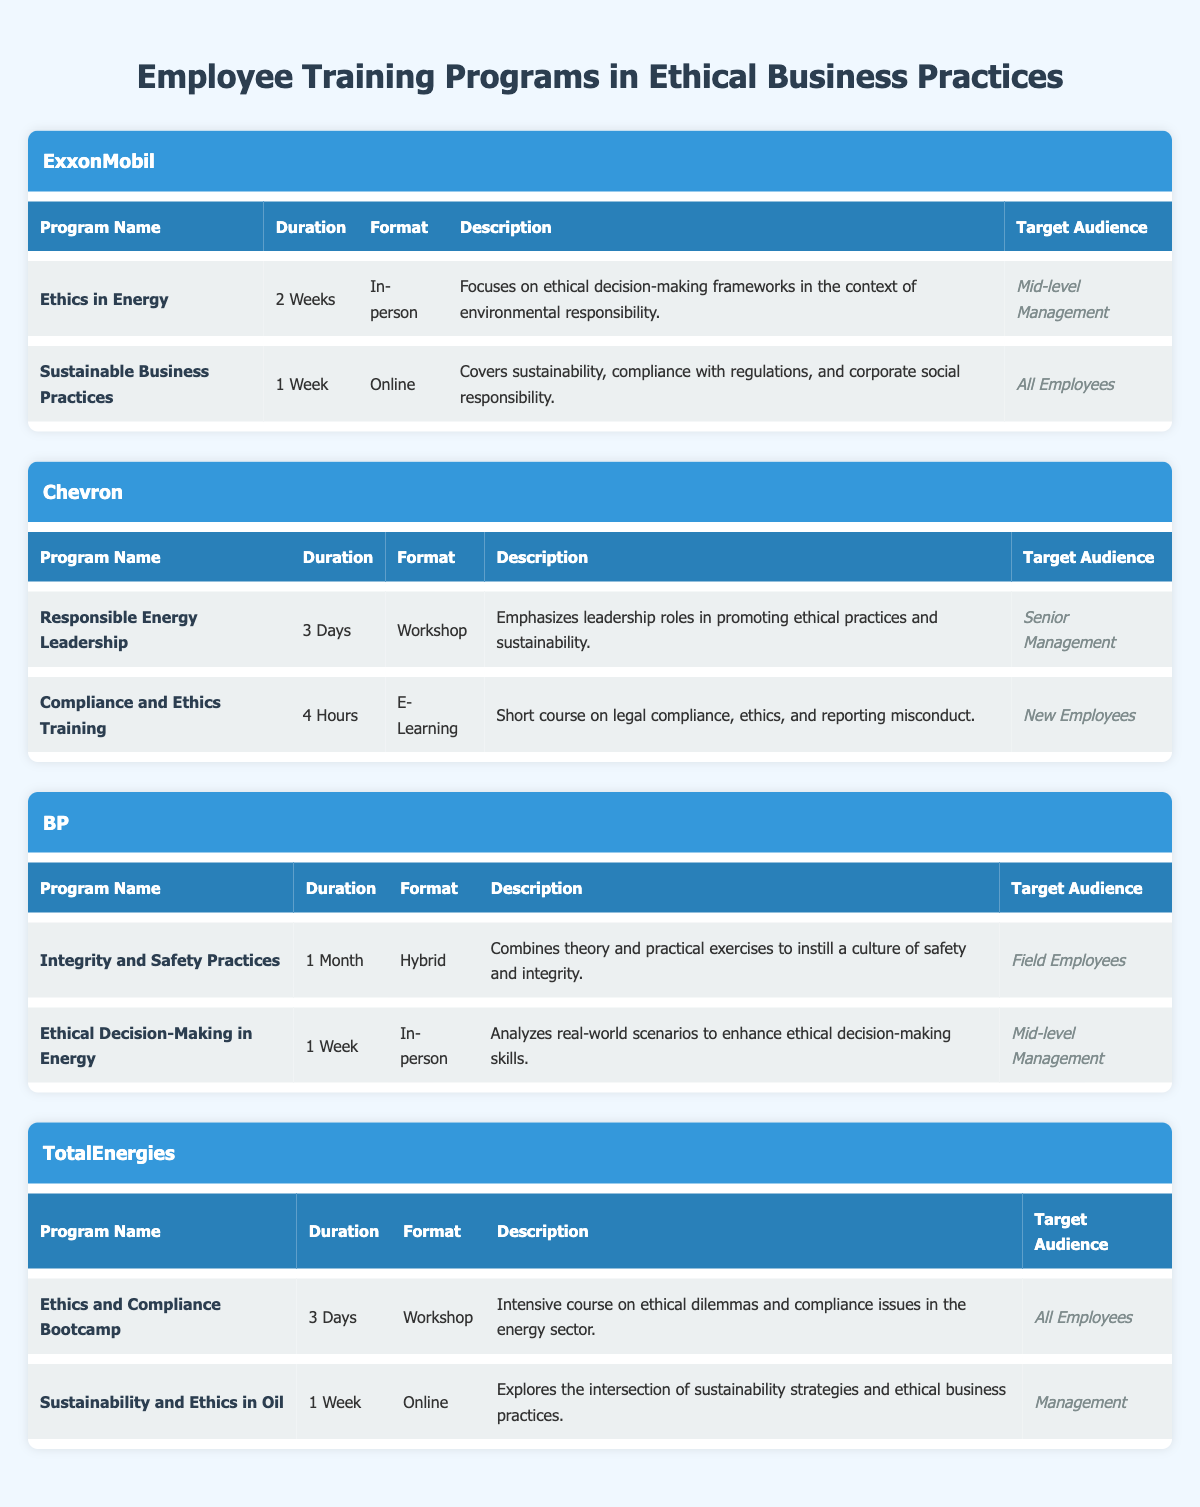What are the target audiences for the training programs at ExxonMobil? From the table, the target audiences listed under ExxonMobil's training programs are "Mid-level Management" for the "Ethics in Energy" program and "All Employees" for the "Sustainable Business Practices" program.
Answer: Mid-level Management and All Employees Which company has a program that lasts for one month? According to the table, BP has a program called "Integrity and Safety Practices" that has a duration of "1 Month."
Answer: BP How many days is the "Responsible Energy Leadership" program? The table states that the "Responsible Energy Leadership" program at Chevron has a duration of "3 Days."
Answer: 3 Days Is there a program specifically for new employees? Yes, the "Compliance and Ethics Training" program at Chevron is targeted at new employees.
Answer: Yes Which company offers online training programs, and how many do they have? Looking at the table, both ExxonMobil and TotalEnergies offer online training programs. ExxonMobil has one ("Sustainable Business Practices") and TotalEnergies has one ("Sustainability and Ethics in Oil") as well. Therefore, they each have one online program, totaling two online training programs across both companies.
Answer: Two What is the shortest training program duration listed in the table? The "Compliance and Ethics Training" program from Chevron has the shortest duration listed at "4 Hours."
Answer: 4 Hours How does the number of programs targeted at management compare to those targeted at all employees? In the table, there are 6 programs total: 4 are targeted at management (ExxonMobil's "Ethics in Energy," BP's "Ethical Decision-Making in Energy," TotalEnergies' "Sustainability and Ethics in Oil," and TotalEnergies' "Ethics and Compliance Bootcamp"), while 2 are targeted at all employees (ExxonMobil's "Sustainable Business Practices" and TotalEnergies' "Ethics and Compliance Bootcamp"). Therefore, there are more programs targeted at management than at all employees.
Answer: More programs for management Which company's program focuses on ethical decision-making frameworks? The "Ethics in Energy" program at ExxonMobil focuses on ethical decision-making frameworks within the context of environmental responsibility.
Answer: ExxonMobil 